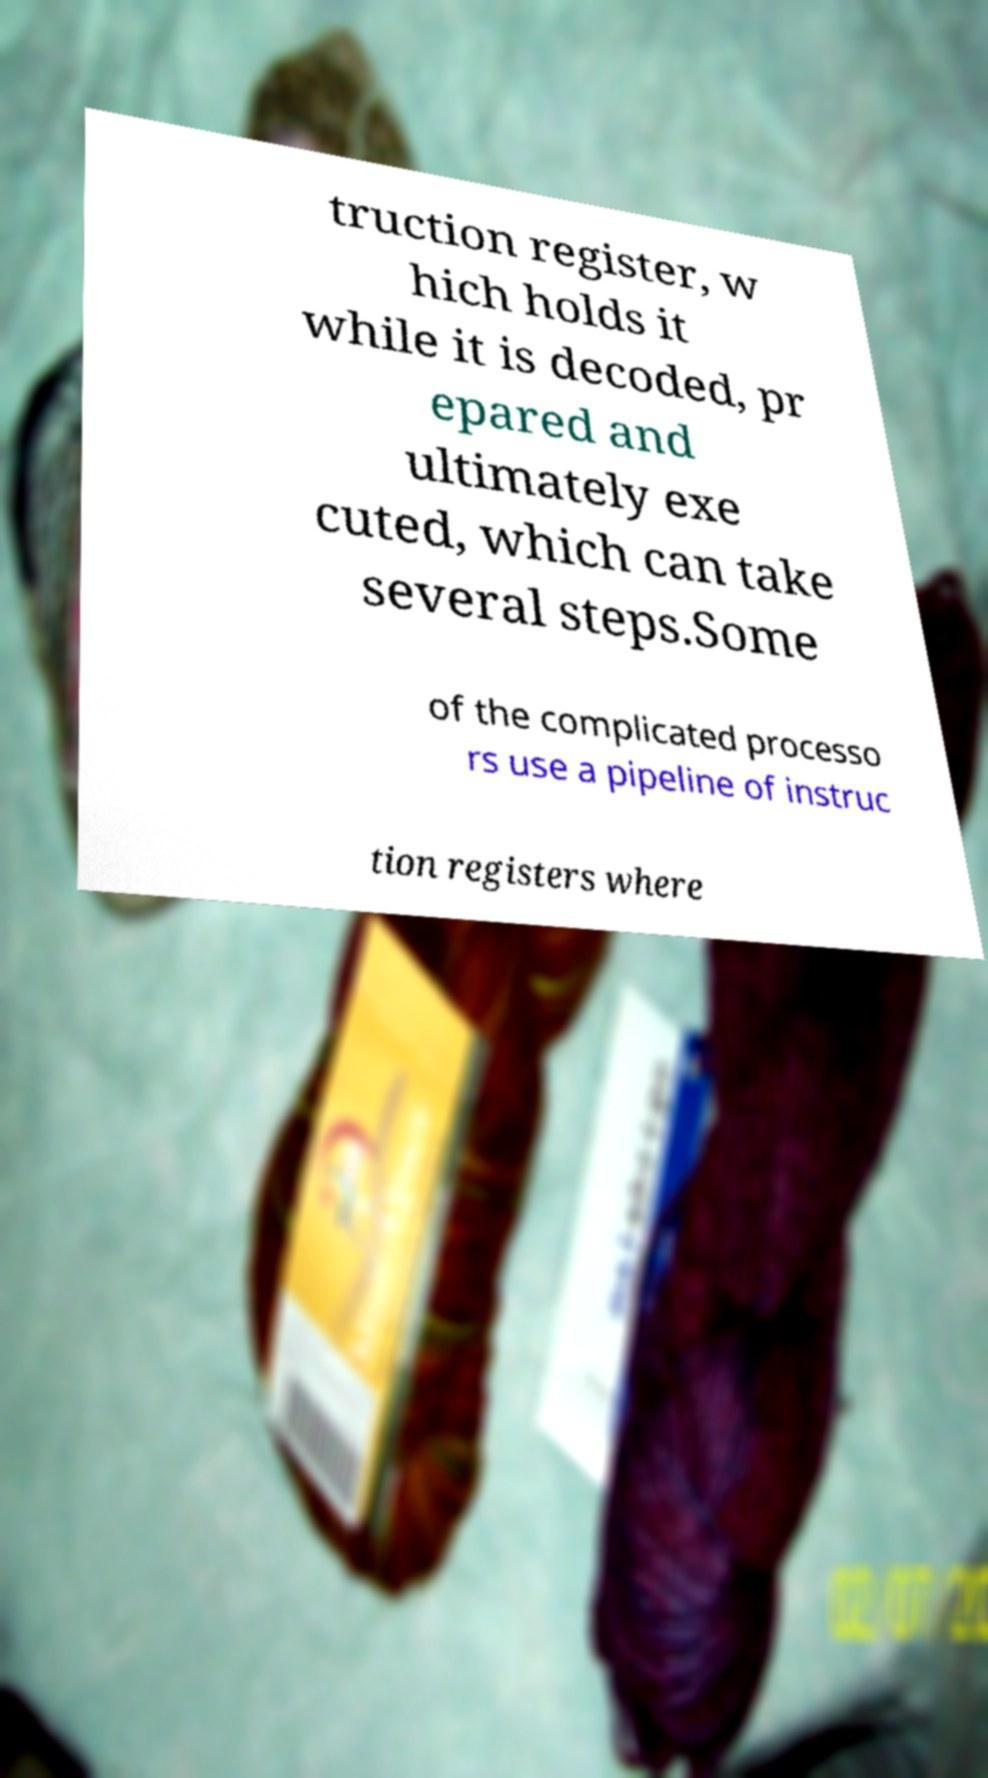I need the written content from this picture converted into text. Can you do that? truction register, w hich holds it while it is decoded, pr epared and ultimately exe cuted, which can take several steps.Some of the complicated processo rs use a pipeline of instruc tion registers where 